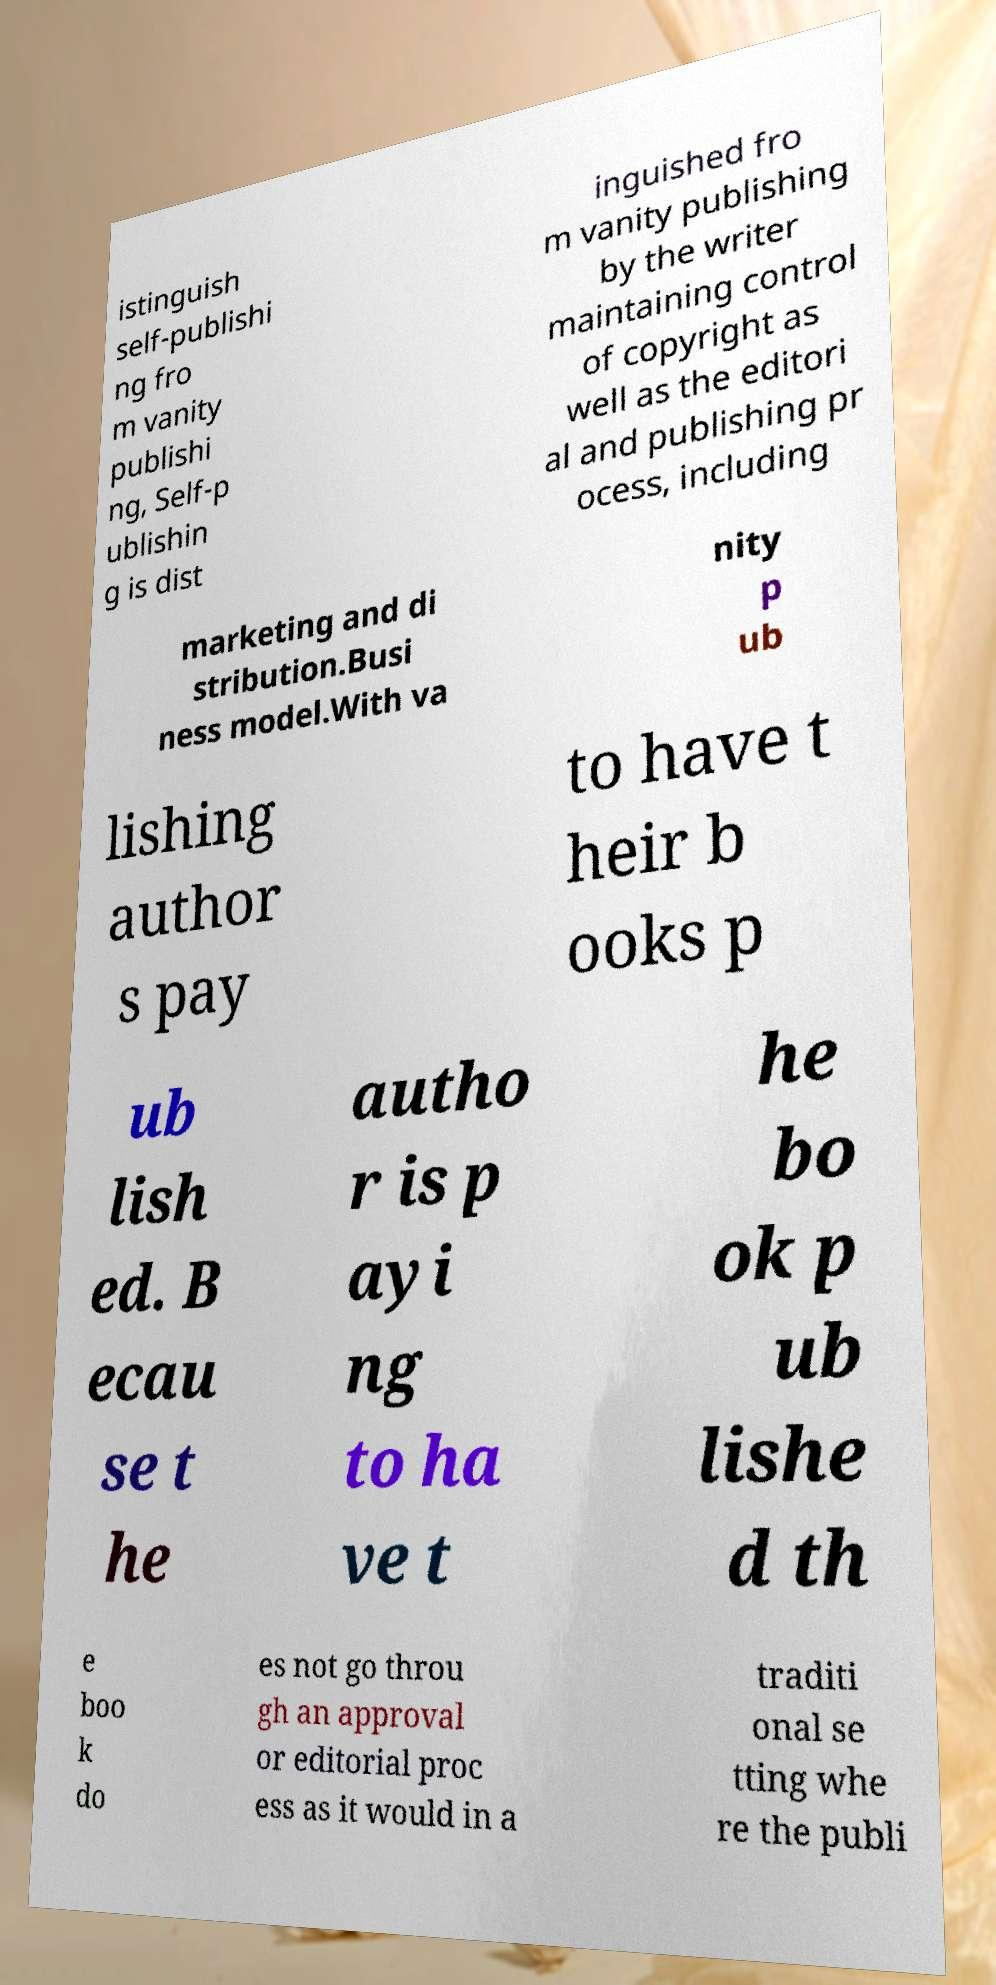Could you extract and type out the text from this image? istinguish self-publishi ng fro m vanity publishi ng, Self-p ublishin g is dist inguished fro m vanity publishing by the writer maintaining control of copyright as well as the editori al and publishing pr ocess, including marketing and di stribution.Busi ness model.With va nity p ub lishing author s pay to have t heir b ooks p ub lish ed. B ecau se t he autho r is p ayi ng to ha ve t he bo ok p ub lishe d th e boo k do es not go throu gh an approval or editorial proc ess as it would in a traditi onal se tting whe re the publi 